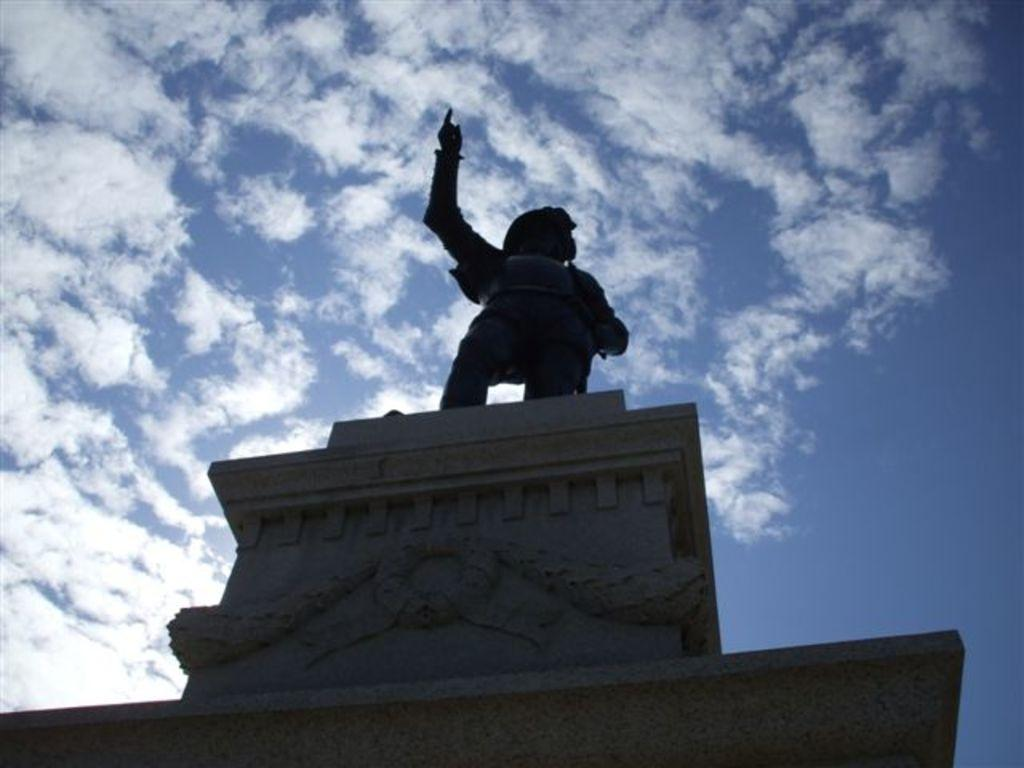What is depicted on the wall in the image? There is a statue on the wall in the image. What is the condition of the sky in the image? The sky is clouded in the image. What decisions were made by the committee in the image? There is no committee present in the image, so no decisions can be made. How does the earthquake affect the statue in the image? There is no earthquake present in the image, so the statue is not affected. 